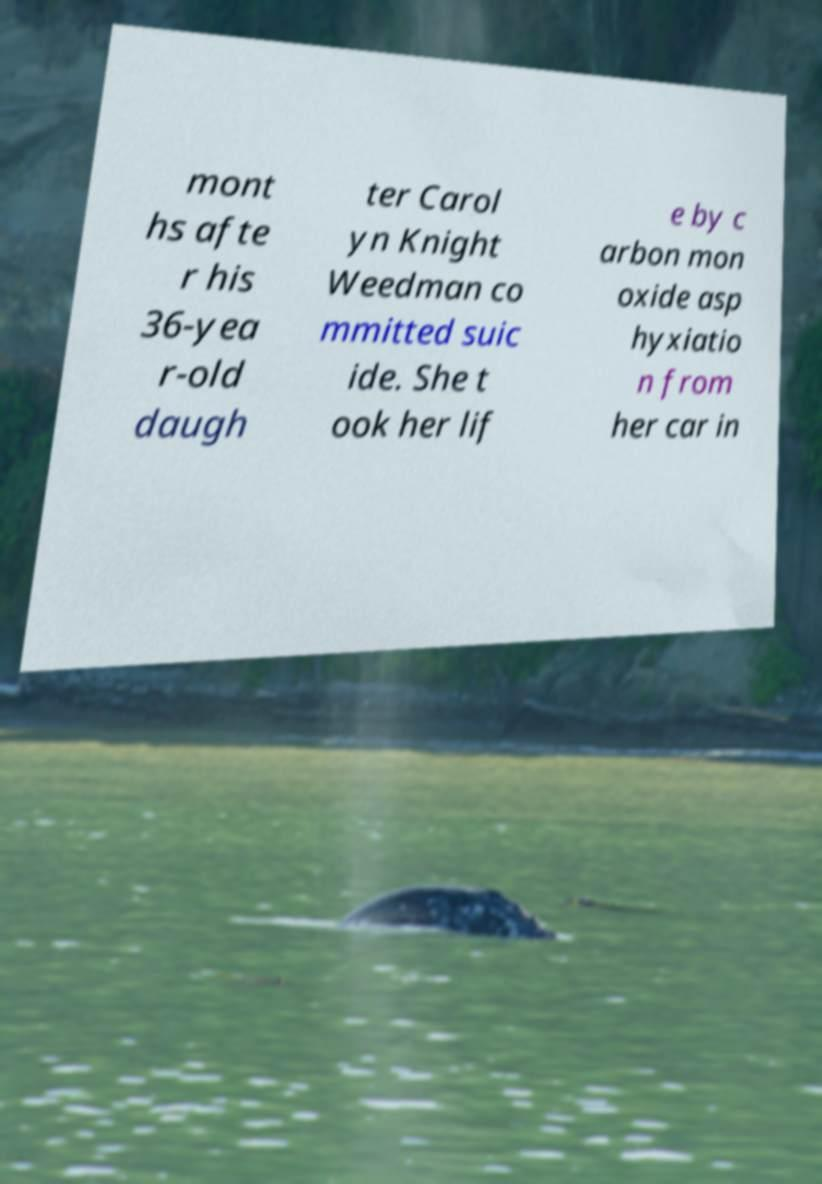Could you assist in decoding the text presented in this image and type it out clearly? mont hs afte r his 36-yea r-old daugh ter Carol yn Knight Weedman co mmitted suic ide. She t ook her lif e by c arbon mon oxide asp hyxiatio n from her car in 